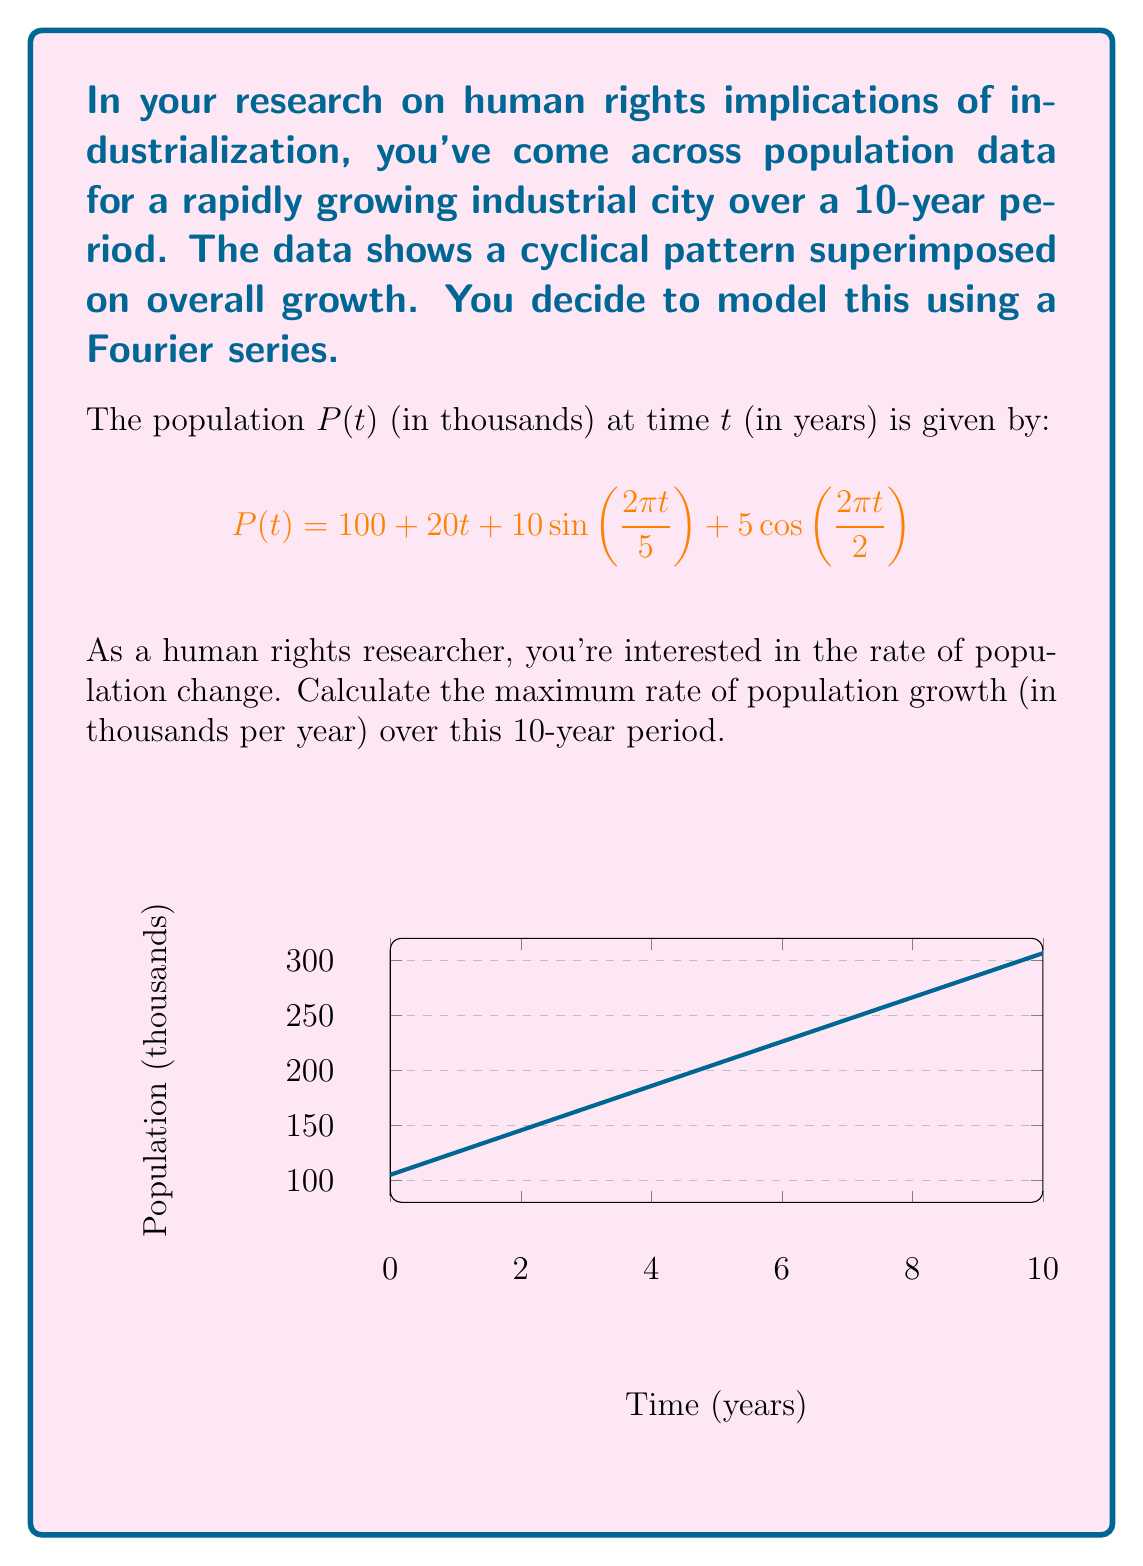Show me your answer to this math problem. To find the maximum rate of population growth, we need to follow these steps:

1) First, we need to find the derivative of P(t) with respect to t. This gives us the rate of population change:

   $$\frac{dP}{dt} = 20 + 10 \cdot \frac{2\pi}{5} \cos(\frac{2\pi t}{5}) - 5 \cdot \frac{2\pi}{2} \sin(\frac{2\pi t}{2})$$

2) Simplify:

   $$\frac{dP}{dt} = 20 + 4\pi \cos(\frac{2\pi t}{5}) - 5\pi \sin(\pi t)$$

3) To find the maximum value of this function, we need to consider its behavior over the 10-year period. The constant term (20) provides a baseline growth rate. The cosine and sine terms cause the rate to oscillate above and below this baseline.

4) The maximum possible value of cosine is 1, and the maximum value of sine is also 1. Therefore, the maximum possible value of the derivative occurs when the cosine term is at its maximum (1) and the sine term is at its minimum (-1):

   $$\max(\frac{dP}{dt}) = 20 + 4\pi \cdot 1 - 5\pi \cdot (-1)$$

5) Calculate:

   $$\max(\frac{dP}{dt}) = 20 + 4\pi + 5\pi = 20 + 9\pi \approx 48.27$$

Therefore, the maximum rate of population growth is approximately 48.27 thousand people per year.
Answer: $20 + 9\pi$ thousand/year 